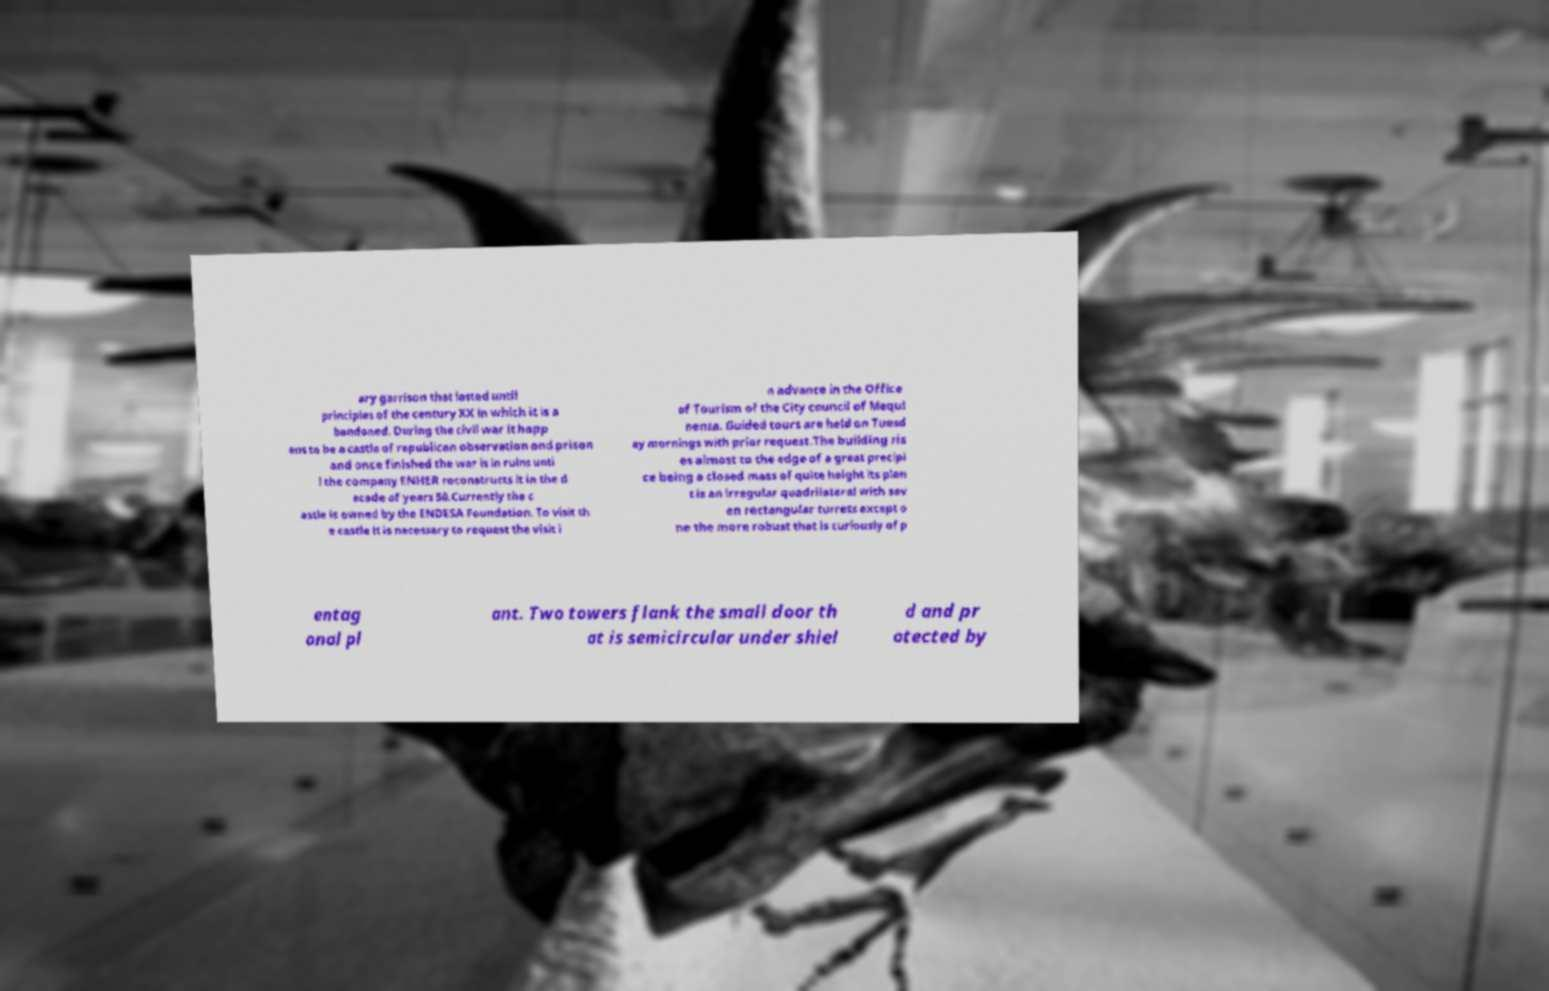Can you accurately transcribe the text from the provided image for me? ary garrison that lasted until principles of the century XX in which it is a bandoned. During the civil war it happ ens to be a castle of republican observation and prison and once finished the war is in ruins unti l the company ENHER reconstructs it in the d ecade of years 50.Currently the c astle is owned by the ENDESA Foundation. To visit th e castle it is necessary to request the visit i n advance in the Office of Tourism of the City council of Mequi nenza. Guided tours are held on Tuesd ay mornings with prior request.The building ris es almost to the edge of a great precipi ce being a closed mass of quite height its plan t is an irregular quadrilateral with sev en rectangular turrets except o ne the more robust that is curiously of p entag onal pl ant. Two towers flank the small door th at is semicircular under shiel d and pr otected by 